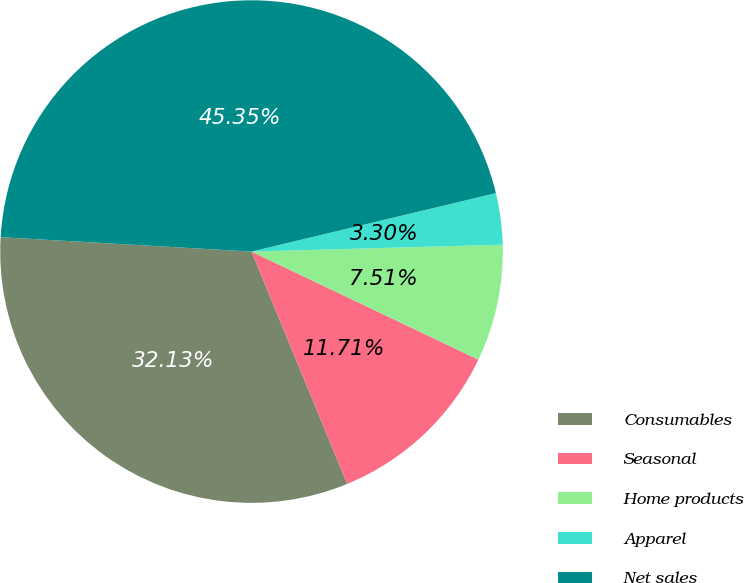Convert chart to OTSL. <chart><loc_0><loc_0><loc_500><loc_500><pie_chart><fcel>Consumables<fcel>Seasonal<fcel>Home products<fcel>Apparel<fcel>Net sales<nl><fcel>32.13%<fcel>11.71%<fcel>7.51%<fcel>3.3%<fcel>45.35%<nl></chart> 